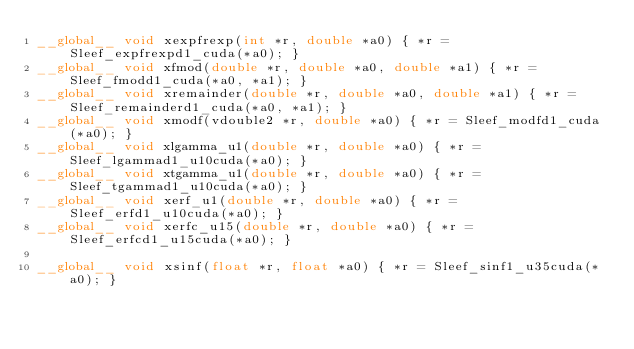<code> <loc_0><loc_0><loc_500><loc_500><_Cuda_>__global__ void xexpfrexp(int *r, double *a0) { *r = Sleef_expfrexpd1_cuda(*a0); }
__global__ void xfmod(double *r, double *a0, double *a1) { *r = Sleef_fmodd1_cuda(*a0, *a1); }
__global__ void xremainder(double *r, double *a0, double *a1) { *r = Sleef_remainderd1_cuda(*a0, *a1); }
__global__ void xmodf(vdouble2 *r, double *a0) { *r = Sleef_modfd1_cuda(*a0); }
__global__ void xlgamma_u1(double *r, double *a0) { *r = Sleef_lgammad1_u10cuda(*a0); }
__global__ void xtgamma_u1(double *r, double *a0) { *r = Sleef_tgammad1_u10cuda(*a0); }
__global__ void xerf_u1(double *r, double *a0) { *r = Sleef_erfd1_u10cuda(*a0); }
__global__ void xerfc_u15(double *r, double *a0) { *r = Sleef_erfcd1_u15cuda(*a0); }

__global__ void xsinf(float *r, float *a0) { *r = Sleef_sinf1_u35cuda(*a0); }</code> 